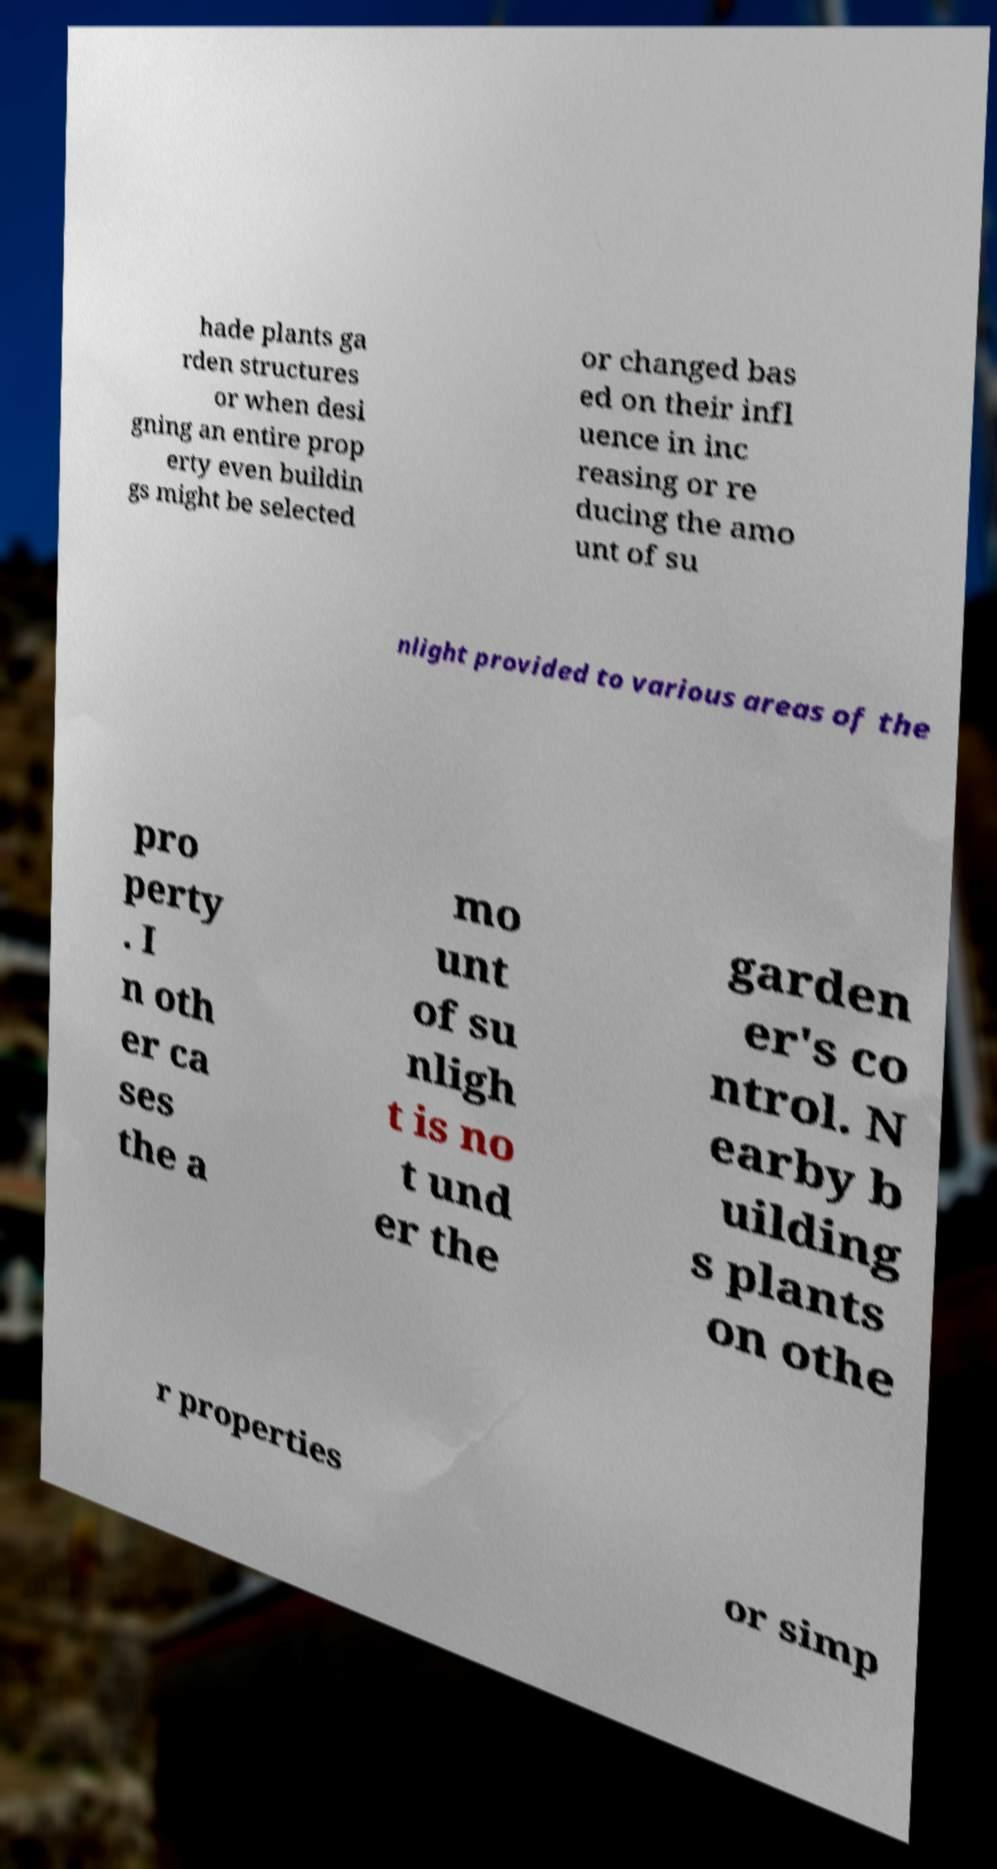What messages or text are displayed in this image? I need them in a readable, typed format. hade plants ga rden structures or when desi gning an entire prop erty even buildin gs might be selected or changed bas ed on their infl uence in inc reasing or re ducing the amo unt of su nlight provided to various areas of the pro perty . I n oth er ca ses the a mo unt of su nligh t is no t und er the garden er's co ntrol. N earby b uilding s plants on othe r properties or simp 